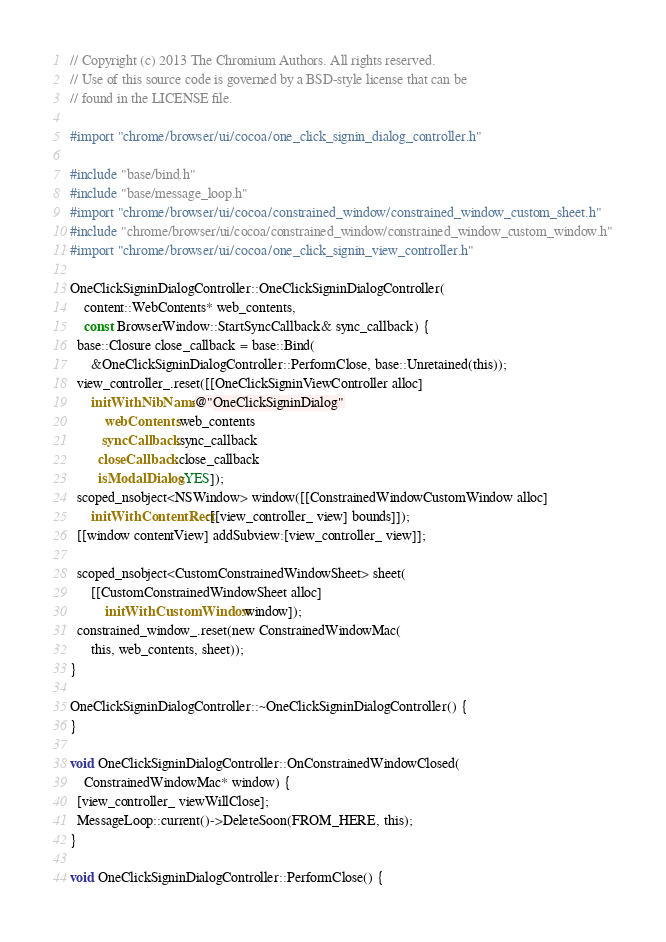Convert code to text. <code><loc_0><loc_0><loc_500><loc_500><_ObjectiveC_>// Copyright (c) 2013 The Chromium Authors. All rights reserved.
// Use of this source code is governed by a BSD-style license that can be
// found in the LICENSE file.

#import "chrome/browser/ui/cocoa/one_click_signin_dialog_controller.h"

#include "base/bind.h"
#include "base/message_loop.h"
#import "chrome/browser/ui/cocoa/constrained_window/constrained_window_custom_sheet.h"
#include "chrome/browser/ui/cocoa/constrained_window/constrained_window_custom_window.h"
#import "chrome/browser/ui/cocoa/one_click_signin_view_controller.h"

OneClickSigninDialogController::OneClickSigninDialogController(
    content::WebContents* web_contents,
    const BrowserWindow::StartSyncCallback& sync_callback) {
  base::Closure close_callback = base::Bind(
      &OneClickSigninDialogController::PerformClose, base::Unretained(this));
  view_controller_.reset([[OneClickSigninViewController alloc]
      initWithNibName:@"OneClickSigninDialog"
          webContents:web_contents
         syncCallback:sync_callback
        closeCallback:close_callback
        isModalDialog:YES]);
  scoped_nsobject<NSWindow> window([[ConstrainedWindowCustomWindow alloc]
      initWithContentRect:[[view_controller_ view] bounds]]);
  [[window contentView] addSubview:[view_controller_ view]];

  scoped_nsobject<CustomConstrainedWindowSheet> sheet(
      [[CustomConstrainedWindowSheet alloc]
          initWithCustomWindow:window]);
  constrained_window_.reset(new ConstrainedWindowMac(
      this, web_contents, sheet));
}

OneClickSigninDialogController::~OneClickSigninDialogController() {
}

void OneClickSigninDialogController::OnConstrainedWindowClosed(
    ConstrainedWindowMac* window) {
  [view_controller_ viewWillClose];
  MessageLoop::current()->DeleteSoon(FROM_HERE, this);
}

void OneClickSigninDialogController::PerformClose() {</code> 